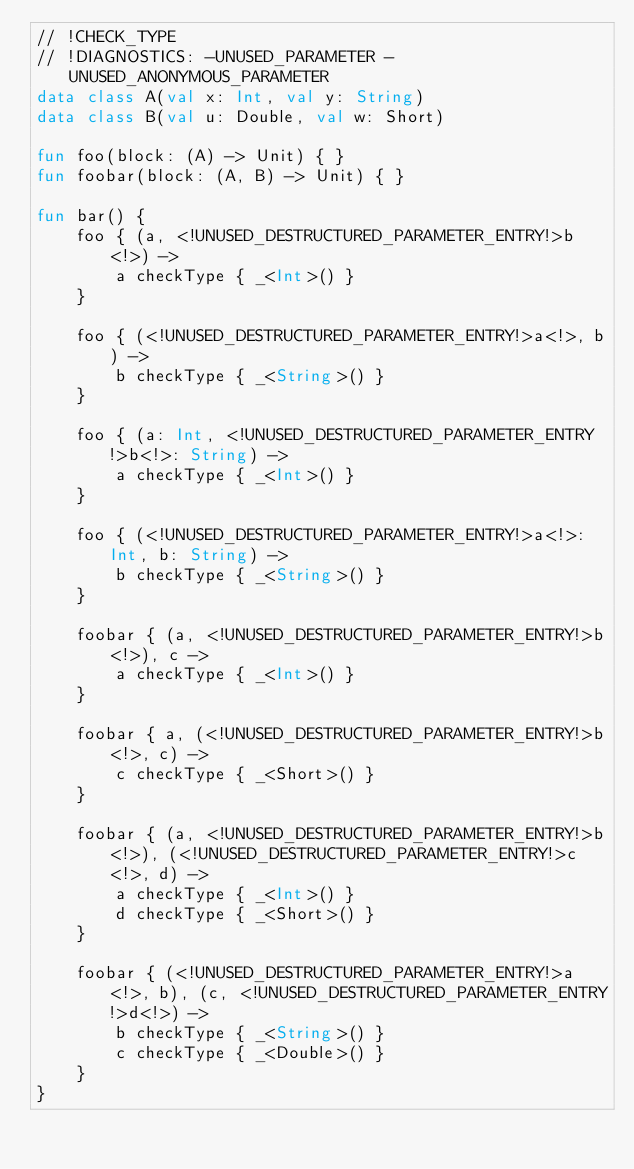<code> <loc_0><loc_0><loc_500><loc_500><_Kotlin_>// !CHECK_TYPE
// !DIAGNOSTICS: -UNUSED_PARAMETER -UNUSED_ANONYMOUS_PARAMETER
data class A(val x: Int, val y: String)
data class B(val u: Double, val w: Short)

fun foo(block: (A) -> Unit) { }
fun foobar(block: (A, B) -> Unit) { }

fun bar() {
    foo { (a, <!UNUSED_DESTRUCTURED_PARAMETER_ENTRY!>b<!>) ->
        a checkType { _<Int>() }
    }

    foo { (<!UNUSED_DESTRUCTURED_PARAMETER_ENTRY!>a<!>, b) ->
        b checkType { _<String>() }
    }

    foo { (a: Int, <!UNUSED_DESTRUCTURED_PARAMETER_ENTRY!>b<!>: String) ->
        a checkType { _<Int>() }
    }

    foo { (<!UNUSED_DESTRUCTURED_PARAMETER_ENTRY!>a<!>: Int, b: String) ->
        b checkType { _<String>() }
    }

    foobar { (a, <!UNUSED_DESTRUCTURED_PARAMETER_ENTRY!>b<!>), c ->
        a checkType { _<Int>() }
    }

    foobar { a, (<!UNUSED_DESTRUCTURED_PARAMETER_ENTRY!>b<!>, c) ->
        c checkType { _<Short>() }
    }

    foobar { (a, <!UNUSED_DESTRUCTURED_PARAMETER_ENTRY!>b<!>), (<!UNUSED_DESTRUCTURED_PARAMETER_ENTRY!>c<!>, d) ->
        a checkType { _<Int>() }
        d checkType { _<Short>() }
    }

    foobar { (<!UNUSED_DESTRUCTURED_PARAMETER_ENTRY!>a<!>, b), (c, <!UNUSED_DESTRUCTURED_PARAMETER_ENTRY!>d<!>) ->
        b checkType { _<String>() }
        c checkType { _<Double>() }
    }
}
</code> 